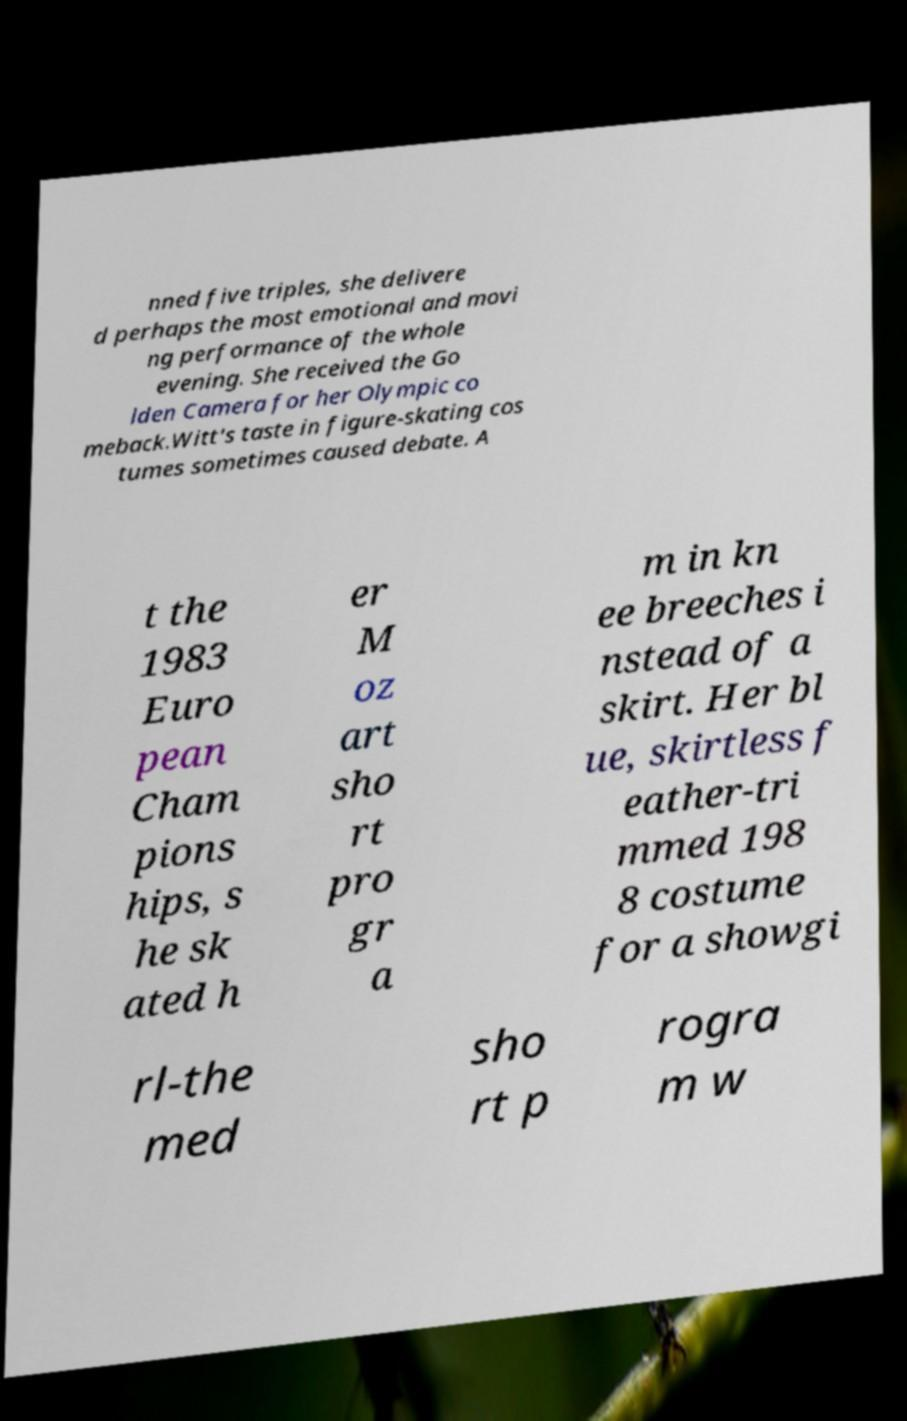Please read and relay the text visible in this image. What does it say? nned five triples, she delivere d perhaps the most emotional and movi ng performance of the whole evening. She received the Go lden Camera for her Olympic co meback.Witt's taste in figure-skating cos tumes sometimes caused debate. A t the 1983 Euro pean Cham pions hips, s he sk ated h er M oz art sho rt pro gr a m in kn ee breeches i nstead of a skirt. Her bl ue, skirtless f eather-tri mmed 198 8 costume for a showgi rl-the med sho rt p rogra m w 